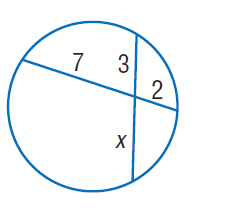Answer the mathemtical geometry problem and directly provide the correct option letter.
Question: Find x. Round to the nearest tenth if necessary. Assume that segments that appear to be tangent are tangent.
Choices: A: 2 B: 3 C: 4.7 D: 7 C 